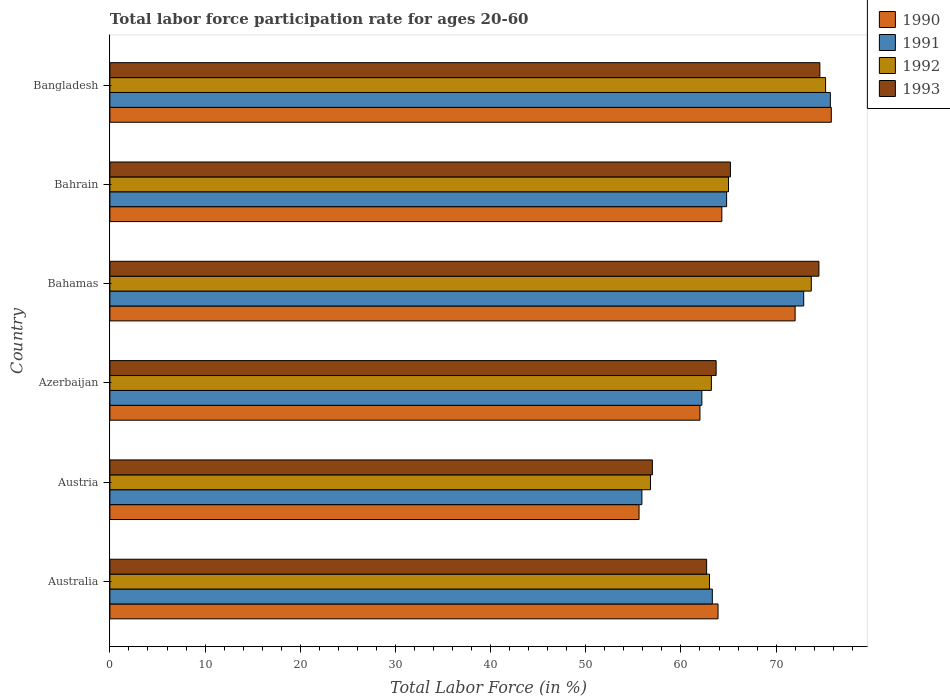Are the number of bars per tick equal to the number of legend labels?
Your answer should be compact. Yes. Are the number of bars on each tick of the Y-axis equal?
Your response must be concise. Yes. How many bars are there on the 1st tick from the top?
Your answer should be compact. 4. What is the label of the 6th group of bars from the top?
Offer a terse response. Australia. What is the labor force participation rate in 1990 in Bahamas?
Keep it short and to the point. 72. Across all countries, what is the maximum labor force participation rate in 1991?
Offer a terse response. 75.7. Across all countries, what is the minimum labor force participation rate in 1993?
Your answer should be compact. 57. In which country was the labor force participation rate in 1990 maximum?
Provide a short and direct response. Bangladesh. What is the total labor force participation rate in 1992 in the graph?
Your answer should be very brief. 396.9. What is the difference between the labor force participation rate in 1991 in Australia and that in Azerbaijan?
Ensure brevity in your answer.  1.1. What is the difference between the labor force participation rate in 1993 in Bahrain and the labor force participation rate in 1990 in Bahamas?
Your answer should be compact. -6.8. What is the average labor force participation rate in 1992 per country?
Provide a succinct answer. 66.15. What is the difference between the labor force participation rate in 1990 and labor force participation rate in 1992 in Azerbaijan?
Your answer should be very brief. -1.2. What is the ratio of the labor force participation rate in 1993 in Austria to that in Azerbaijan?
Provide a succinct answer. 0.89. Is the difference between the labor force participation rate in 1990 in Austria and Azerbaijan greater than the difference between the labor force participation rate in 1992 in Austria and Azerbaijan?
Ensure brevity in your answer.  Yes. What is the difference between the highest and the second highest labor force participation rate in 1993?
Your answer should be compact. 0.1. What is the difference between the highest and the lowest labor force participation rate in 1991?
Your answer should be very brief. 19.8. In how many countries, is the labor force participation rate in 1992 greater than the average labor force participation rate in 1992 taken over all countries?
Offer a very short reply. 2. What does the 4th bar from the bottom in Bahrain represents?
Your answer should be compact. 1993. Is it the case that in every country, the sum of the labor force participation rate in 1990 and labor force participation rate in 1991 is greater than the labor force participation rate in 1993?
Keep it short and to the point. Yes. Are all the bars in the graph horizontal?
Your response must be concise. Yes. Are the values on the major ticks of X-axis written in scientific E-notation?
Your answer should be very brief. No. Does the graph contain any zero values?
Offer a very short reply. No. Does the graph contain grids?
Keep it short and to the point. No. Where does the legend appear in the graph?
Your response must be concise. Top right. How many legend labels are there?
Your response must be concise. 4. How are the legend labels stacked?
Your answer should be compact. Vertical. What is the title of the graph?
Your answer should be very brief. Total labor force participation rate for ages 20-60. Does "1992" appear as one of the legend labels in the graph?
Provide a short and direct response. Yes. What is the label or title of the Y-axis?
Provide a short and direct response. Country. What is the Total Labor Force (in %) in 1990 in Australia?
Offer a terse response. 63.9. What is the Total Labor Force (in %) in 1991 in Australia?
Your answer should be very brief. 63.3. What is the Total Labor Force (in %) in 1993 in Australia?
Offer a terse response. 62.7. What is the Total Labor Force (in %) of 1990 in Austria?
Make the answer very short. 55.6. What is the Total Labor Force (in %) of 1991 in Austria?
Give a very brief answer. 55.9. What is the Total Labor Force (in %) of 1992 in Austria?
Ensure brevity in your answer.  56.8. What is the Total Labor Force (in %) in 1993 in Austria?
Offer a terse response. 57. What is the Total Labor Force (in %) in 1991 in Azerbaijan?
Your answer should be very brief. 62.2. What is the Total Labor Force (in %) of 1992 in Azerbaijan?
Give a very brief answer. 63.2. What is the Total Labor Force (in %) of 1993 in Azerbaijan?
Make the answer very short. 63.7. What is the Total Labor Force (in %) in 1990 in Bahamas?
Give a very brief answer. 72. What is the Total Labor Force (in %) in 1991 in Bahamas?
Offer a terse response. 72.9. What is the Total Labor Force (in %) in 1992 in Bahamas?
Keep it short and to the point. 73.7. What is the Total Labor Force (in %) of 1993 in Bahamas?
Give a very brief answer. 74.5. What is the Total Labor Force (in %) in 1990 in Bahrain?
Your response must be concise. 64.3. What is the Total Labor Force (in %) of 1991 in Bahrain?
Your response must be concise. 64.8. What is the Total Labor Force (in %) of 1992 in Bahrain?
Your answer should be very brief. 65. What is the Total Labor Force (in %) of 1993 in Bahrain?
Your response must be concise. 65.2. What is the Total Labor Force (in %) of 1990 in Bangladesh?
Your response must be concise. 75.8. What is the Total Labor Force (in %) of 1991 in Bangladesh?
Your answer should be very brief. 75.7. What is the Total Labor Force (in %) of 1992 in Bangladesh?
Your answer should be very brief. 75.2. What is the Total Labor Force (in %) of 1993 in Bangladesh?
Provide a succinct answer. 74.6. Across all countries, what is the maximum Total Labor Force (in %) in 1990?
Your answer should be very brief. 75.8. Across all countries, what is the maximum Total Labor Force (in %) of 1991?
Keep it short and to the point. 75.7. Across all countries, what is the maximum Total Labor Force (in %) in 1992?
Ensure brevity in your answer.  75.2. Across all countries, what is the maximum Total Labor Force (in %) of 1993?
Offer a terse response. 74.6. Across all countries, what is the minimum Total Labor Force (in %) of 1990?
Your response must be concise. 55.6. Across all countries, what is the minimum Total Labor Force (in %) in 1991?
Provide a short and direct response. 55.9. Across all countries, what is the minimum Total Labor Force (in %) in 1992?
Your answer should be compact. 56.8. What is the total Total Labor Force (in %) in 1990 in the graph?
Make the answer very short. 393.6. What is the total Total Labor Force (in %) in 1991 in the graph?
Your answer should be compact. 394.8. What is the total Total Labor Force (in %) of 1992 in the graph?
Your answer should be very brief. 396.9. What is the total Total Labor Force (in %) of 1993 in the graph?
Provide a short and direct response. 397.7. What is the difference between the Total Labor Force (in %) of 1992 in Australia and that in Austria?
Offer a terse response. 6.2. What is the difference between the Total Labor Force (in %) in 1991 in Australia and that in Azerbaijan?
Ensure brevity in your answer.  1.1. What is the difference between the Total Labor Force (in %) in 1992 in Australia and that in Azerbaijan?
Ensure brevity in your answer.  -0.2. What is the difference between the Total Labor Force (in %) of 1993 in Australia and that in Azerbaijan?
Your answer should be compact. -1. What is the difference between the Total Labor Force (in %) of 1992 in Australia and that in Bahamas?
Provide a short and direct response. -10.7. What is the difference between the Total Labor Force (in %) in 1993 in Australia and that in Bahamas?
Make the answer very short. -11.8. What is the difference between the Total Labor Force (in %) of 1990 in Australia and that in Bahrain?
Ensure brevity in your answer.  -0.4. What is the difference between the Total Labor Force (in %) in 1992 in Australia and that in Bahrain?
Provide a short and direct response. -2. What is the difference between the Total Labor Force (in %) of 1990 in Australia and that in Bangladesh?
Your answer should be compact. -11.9. What is the difference between the Total Labor Force (in %) of 1991 in Australia and that in Bangladesh?
Give a very brief answer. -12.4. What is the difference between the Total Labor Force (in %) in 1993 in Australia and that in Bangladesh?
Give a very brief answer. -11.9. What is the difference between the Total Labor Force (in %) in 1991 in Austria and that in Azerbaijan?
Your answer should be very brief. -6.3. What is the difference between the Total Labor Force (in %) of 1992 in Austria and that in Azerbaijan?
Make the answer very short. -6.4. What is the difference between the Total Labor Force (in %) of 1993 in Austria and that in Azerbaijan?
Your response must be concise. -6.7. What is the difference between the Total Labor Force (in %) in 1990 in Austria and that in Bahamas?
Ensure brevity in your answer.  -16.4. What is the difference between the Total Labor Force (in %) in 1992 in Austria and that in Bahamas?
Offer a terse response. -16.9. What is the difference between the Total Labor Force (in %) of 1993 in Austria and that in Bahamas?
Offer a terse response. -17.5. What is the difference between the Total Labor Force (in %) of 1991 in Austria and that in Bahrain?
Keep it short and to the point. -8.9. What is the difference between the Total Labor Force (in %) of 1992 in Austria and that in Bahrain?
Offer a terse response. -8.2. What is the difference between the Total Labor Force (in %) in 1993 in Austria and that in Bahrain?
Offer a terse response. -8.2. What is the difference between the Total Labor Force (in %) of 1990 in Austria and that in Bangladesh?
Ensure brevity in your answer.  -20.2. What is the difference between the Total Labor Force (in %) of 1991 in Austria and that in Bangladesh?
Ensure brevity in your answer.  -19.8. What is the difference between the Total Labor Force (in %) in 1992 in Austria and that in Bangladesh?
Keep it short and to the point. -18.4. What is the difference between the Total Labor Force (in %) in 1993 in Austria and that in Bangladesh?
Ensure brevity in your answer.  -17.6. What is the difference between the Total Labor Force (in %) in 1990 in Azerbaijan and that in Bahamas?
Offer a terse response. -10. What is the difference between the Total Labor Force (in %) of 1991 in Azerbaijan and that in Bahrain?
Offer a very short reply. -2.6. What is the difference between the Total Labor Force (in %) of 1991 in Azerbaijan and that in Bangladesh?
Ensure brevity in your answer.  -13.5. What is the difference between the Total Labor Force (in %) in 1993 in Azerbaijan and that in Bangladesh?
Provide a succinct answer. -10.9. What is the difference between the Total Labor Force (in %) in 1991 in Bahamas and that in Bahrain?
Your response must be concise. 8.1. What is the difference between the Total Labor Force (in %) in 1992 in Bahamas and that in Bahrain?
Your answer should be very brief. 8.7. What is the difference between the Total Labor Force (in %) of 1991 in Bahamas and that in Bangladesh?
Your answer should be very brief. -2.8. What is the difference between the Total Labor Force (in %) of 1992 in Bahamas and that in Bangladesh?
Keep it short and to the point. -1.5. What is the difference between the Total Labor Force (in %) of 1991 in Bahrain and that in Bangladesh?
Ensure brevity in your answer.  -10.9. What is the difference between the Total Labor Force (in %) of 1992 in Bahrain and that in Bangladesh?
Provide a short and direct response. -10.2. What is the difference between the Total Labor Force (in %) of 1990 in Australia and the Total Labor Force (in %) of 1993 in Austria?
Provide a succinct answer. 6.9. What is the difference between the Total Labor Force (in %) of 1991 in Australia and the Total Labor Force (in %) of 1993 in Austria?
Ensure brevity in your answer.  6.3. What is the difference between the Total Labor Force (in %) of 1990 in Australia and the Total Labor Force (in %) of 1991 in Azerbaijan?
Your answer should be very brief. 1.7. What is the difference between the Total Labor Force (in %) in 1990 in Australia and the Total Labor Force (in %) in 1992 in Azerbaijan?
Keep it short and to the point. 0.7. What is the difference between the Total Labor Force (in %) in 1992 in Australia and the Total Labor Force (in %) in 1993 in Azerbaijan?
Offer a very short reply. -0.7. What is the difference between the Total Labor Force (in %) in 1990 in Australia and the Total Labor Force (in %) in 1991 in Bahamas?
Offer a very short reply. -9. What is the difference between the Total Labor Force (in %) of 1990 in Australia and the Total Labor Force (in %) of 1993 in Bahamas?
Your answer should be compact. -10.6. What is the difference between the Total Labor Force (in %) of 1991 in Australia and the Total Labor Force (in %) of 1992 in Bahamas?
Give a very brief answer. -10.4. What is the difference between the Total Labor Force (in %) in 1991 in Australia and the Total Labor Force (in %) in 1993 in Bahamas?
Your response must be concise. -11.2. What is the difference between the Total Labor Force (in %) of 1992 in Australia and the Total Labor Force (in %) of 1993 in Bahamas?
Offer a terse response. -11.5. What is the difference between the Total Labor Force (in %) in 1991 in Australia and the Total Labor Force (in %) in 1993 in Bahrain?
Keep it short and to the point. -1.9. What is the difference between the Total Labor Force (in %) in 1990 in Australia and the Total Labor Force (in %) in 1991 in Bangladesh?
Offer a very short reply. -11.8. What is the difference between the Total Labor Force (in %) in 1990 in Australia and the Total Labor Force (in %) in 1992 in Bangladesh?
Offer a very short reply. -11.3. What is the difference between the Total Labor Force (in %) in 1990 in Australia and the Total Labor Force (in %) in 1993 in Bangladesh?
Offer a terse response. -10.7. What is the difference between the Total Labor Force (in %) in 1991 in Australia and the Total Labor Force (in %) in 1992 in Bangladesh?
Ensure brevity in your answer.  -11.9. What is the difference between the Total Labor Force (in %) of 1990 in Austria and the Total Labor Force (in %) of 1992 in Azerbaijan?
Provide a short and direct response. -7.6. What is the difference between the Total Labor Force (in %) in 1990 in Austria and the Total Labor Force (in %) in 1993 in Azerbaijan?
Offer a terse response. -8.1. What is the difference between the Total Labor Force (in %) in 1990 in Austria and the Total Labor Force (in %) in 1991 in Bahamas?
Ensure brevity in your answer.  -17.3. What is the difference between the Total Labor Force (in %) in 1990 in Austria and the Total Labor Force (in %) in 1992 in Bahamas?
Your answer should be compact. -18.1. What is the difference between the Total Labor Force (in %) of 1990 in Austria and the Total Labor Force (in %) of 1993 in Bahamas?
Your answer should be compact. -18.9. What is the difference between the Total Labor Force (in %) in 1991 in Austria and the Total Labor Force (in %) in 1992 in Bahamas?
Provide a succinct answer. -17.8. What is the difference between the Total Labor Force (in %) in 1991 in Austria and the Total Labor Force (in %) in 1993 in Bahamas?
Provide a short and direct response. -18.6. What is the difference between the Total Labor Force (in %) of 1992 in Austria and the Total Labor Force (in %) of 1993 in Bahamas?
Offer a very short reply. -17.7. What is the difference between the Total Labor Force (in %) of 1990 in Austria and the Total Labor Force (in %) of 1992 in Bahrain?
Make the answer very short. -9.4. What is the difference between the Total Labor Force (in %) of 1990 in Austria and the Total Labor Force (in %) of 1993 in Bahrain?
Ensure brevity in your answer.  -9.6. What is the difference between the Total Labor Force (in %) of 1991 in Austria and the Total Labor Force (in %) of 1993 in Bahrain?
Give a very brief answer. -9.3. What is the difference between the Total Labor Force (in %) in 1990 in Austria and the Total Labor Force (in %) in 1991 in Bangladesh?
Give a very brief answer. -20.1. What is the difference between the Total Labor Force (in %) in 1990 in Austria and the Total Labor Force (in %) in 1992 in Bangladesh?
Keep it short and to the point. -19.6. What is the difference between the Total Labor Force (in %) in 1990 in Austria and the Total Labor Force (in %) in 1993 in Bangladesh?
Provide a short and direct response. -19. What is the difference between the Total Labor Force (in %) in 1991 in Austria and the Total Labor Force (in %) in 1992 in Bangladesh?
Make the answer very short. -19.3. What is the difference between the Total Labor Force (in %) of 1991 in Austria and the Total Labor Force (in %) of 1993 in Bangladesh?
Provide a succinct answer. -18.7. What is the difference between the Total Labor Force (in %) of 1992 in Austria and the Total Labor Force (in %) of 1993 in Bangladesh?
Provide a short and direct response. -17.8. What is the difference between the Total Labor Force (in %) in 1990 in Azerbaijan and the Total Labor Force (in %) in 1991 in Bahamas?
Give a very brief answer. -10.9. What is the difference between the Total Labor Force (in %) in 1992 in Azerbaijan and the Total Labor Force (in %) in 1993 in Bahamas?
Ensure brevity in your answer.  -11.3. What is the difference between the Total Labor Force (in %) in 1990 in Azerbaijan and the Total Labor Force (in %) in 1991 in Bahrain?
Your response must be concise. -2.8. What is the difference between the Total Labor Force (in %) in 1990 in Azerbaijan and the Total Labor Force (in %) in 1992 in Bahrain?
Provide a succinct answer. -3. What is the difference between the Total Labor Force (in %) in 1990 in Azerbaijan and the Total Labor Force (in %) in 1993 in Bahrain?
Keep it short and to the point. -3.2. What is the difference between the Total Labor Force (in %) of 1991 in Azerbaijan and the Total Labor Force (in %) of 1992 in Bahrain?
Your answer should be very brief. -2.8. What is the difference between the Total Labor Force (in %) in 1992 in Azerbaijan and the Total Labor Force (in %) in 1993 in Bahrain?
Your answer should be compact. -2. What is the difference between the Total Labor Force (in %) of 1990 in Azerbaijan and the Total Labor Force (in %) of 1991 in Bangladesh?
Make the answer very short. -13.7. What is the difference between the Total Labor Force (in %) of 1990 in Azerbaijan and the Total Labor Force (in %) of 1992 in Bangladesh?
Your response must be concise. -13.2. What is the difference between the Total Labor Force (in %) in 1991 in Azerbaijan and the Total Labor Force (in %) in 1993 in Bangladesh?
Your answer should be very brief. -12.4. What is the difference between the Total Labor Force (in %) of 1990 in Bahamas and the Total Labor Force (in %) of 1991 in Bahrain?
Make the answer very short. 7.2. What is the difference between the Total Labor Force (in %) of 1990 in Bahamas and the Total Labor Force (in %) of 1992 in Bahrain?
Provide a succinct answer. 7. What is the difference between the Total Labor Force (in %) in 1991 in Bahamas and the Total Labor Force (in %) in 1992 in Bahrain?
Your response must be concise. 7.9. What is the difference between the Total Labor Force (in %) in 1991 in Bahamas and the Total Labor Force (in %) in 1993 in Bahrain?
Offer a terse response. 7.7. What is the difference between the Total Labor Force (in %) in 1990 in Bahrain and the Total Labor Force (in %) in 1993 in Bangladesh?
Give a very brief answer. -10.3. What is the average Total Labor Force (in %) of 1990 per country?
Your answer should be very brief. 65.6. What is the average Total Labor Force (in %) of 1991 per country?
Give a very brief answer. 65.8. What is the average Total Labor Force (in %) of 1992 per country?
Provide a short and direct response. 66.15. What is the average Total Labor Force (in %) in 1993 per country?
Ensure brevity in your answer.  66.28. What is the difference between the Total Labor Force (in %) in 1991 and Total Labor Force (in %) in 1992 in Australia?
Your answer should be compact. 0.3. What is the difference between the Total Labor Force (in %) of 1990 and Total Labor Force (in %) of 1993 in Austria?
Provide a succinct answer. -1.4. What is the difference between the Total Labor Force (in %) of 1990 and Total Labor Force (in %) of 1993 in Azerbaijan?
Your answer should be very brief. -1.7. What is the difference between the Total Labor Force (in %) of 1991 and Total Labor Force (in %) of 1993 in Azerbaijan?
Keep it short and to the point. -1.5. What is the difference between the Total Labor Force (in %) of 1990 and Total Labor Force (in %) of 1991 in Bahamas?
Your answer should be very brief. -0.9. What is the difference between the Total Labor Force (in %) of 1990 and Total Labor Force (in %) of 1993 in Bahamas?
Offer a very short reply. -2.5. What is the difference between the Total Labor Force (in %) in 1991 and Total Labor Force (in %) in 1992 in Bahamas?
Your response must be concise. -0.8. What is the difference between the Total Labor Force (in %) of 1992 and Total Labor Force (in %) of 1993 in Bahamas?
Offer a terse response. -0.8. What is the difference between the Total Labor Force (in %) of 1990 and Total Labor Force (in %) of 1991 in Bangladesh?
Your response must be concise. 0.1. What is the difference between the Total Labor Force (in %) of 1990 and Total Labor Force (in %) of 1992 in Bangladesh?
Your answer should be compact. 0.6. What is the difference between the Total Labor Force (in %) in 1990 and Total Labor Force (in %) in 1993 in Bangladesh?
Provide a short and direct response. 1.2. What is the difference between the Total Labor Force (in %) of 1991 and Total Labor Force (in %) of 1992 in Bangladesh?
Offer a terse response. 0.5. What is the difference between the Total Labor Force (in %) in 1991 and Total Labor Force (in %) in 1993 in Bangladesh?
Provide a short and direct response. 1.1. What is the difference between the Total Labor Force (in %) in 1992 and Total Labor Force (in %) in 1993 in Bangladesh?
Your answer should be compact. 0.6. What is the ratio of the Total Labor Force (in %) of 1990 in Australia to that in Austria?
Provide a short and direct response. 1.15. What is the ratio of the Total Labor Force (in %) in 1991 in Australia to that in Austria?
Keep it short and to the point. 1.13. What is the ratio of the Total Labor Force (in %) in 1992 in Australia to that in Austria?
Ensure brevity in your answer.  1.11. What is the ratio of the Total Labor Force (in %) of 1990 in Australia to that in Azerbaijan?
Give a very brief answer. 1.03. What is the ratio of the Total Labor Force (in %) of 1991 in Australia to that in Azerbaijan?
Your answer should be very brief. 1.02. What is the ratio of the Total Labor Force (in %) of 1993 in Australia to that in Azerbaijan?
Offer a very short reply. 0.98. What is the ratio of the Total Labor Force (in %) of 1990 in Australia to that in Bahamas?
Your answer should be very brief. 0.89. What is the ratio of the Total Labor Force (in %) of 1991 in Australia to that in Bahamas?
Keep it short and to the point. 0.87. What is the ratio of the Total Labor Force (in %) in 1992 in Australia to that in Bahamas?
Offer a terse response. 0.85. What is the ratio of the Total Labor Force (in %) in 1993 in Australia to that in Bahamas?
Give a very brief answer. 0.84. What is the ratio of the Total Labor Force (in %) in 1990 in Australia to that in Bahrain?
Keep it short and to the point. 0.99. What is the ratio of the Total Labor Force (in %) in 1991 in Australia to that in Bahrain?
Keep it short and to the point. 0.98. What is the ratio of the Total Labor Force (in %) in 1992 in Australia to that in Bahrain?
Your response must be concise. 0.97. What is the ratio of the Total Labor Force (in %) in 1993 in Australia to that in Bahrain?
Provide a short and direct response. 0.96. What is the ratio of the Total Labor Force (in %) in 1990 in Australia to that in Bangladesh?
Your response must be concise. 0.84. What is the ratio of the Total Labor Force (in %) of 1991 in Australia to that in Bangladesh?
Provide a short and direct response. 0.84. What is the ratio of the Total Labor Force (in %) in 1992 in Australia to that in Bangladesh?
Ensure brevity in your answer.  0.84. What is the ratio of the Total Labor Force (in %) of 1993 in Australia to that in Bangladesh?
Ensure brevity in your answer.  0.84. What is the ratio of the Total Labor Force (in %) of 1990 in Austria to that in Azerbaijan?
Ensure brevity in your answer.  0.9. What is the ratio of the Total Labor Force (in %) in 1991 in Austria to that in Azerbaijan?
Make the answer very short. 0.9. What is the ratio of the Total Labor Force (in %) of 1992 in Austria to that in Azerbaijan?
Ensure brevity in your answer.  0.9. What is the ratio of the Total Labor Force (in %) of 1993 in Austria to that in Azerbaijan?
Keep it short and to the point. 0.89. What is the ratio of the Total Labor Force (in %) in 1990 in Austria to that in Bahamas?
Provide a succinct answer. 0.77. What is the ratio of the Total Labor Force (in %) of 1991 in Austria to that in Bahamas?
Keep it short and to the point. 0.77. What is the ratio of the Total Labor Force (in %) in 1992 in Austria to that in Bahamas?
Offer a terse response. 0.77. What is the ratio of the Total Labor Force (in %) of 1993 in Austria to that in Bahamas?
Offer a terse response. 0.77. What is the ratio of the Total Labor Force (in %) in 1990 in Austria to that in Bahrain?
Provide a succinct answer. 0.86. What is the ratio of the Total Labor Force (in %) of 1991 in Austria to that in Bahrain?
Your response must be concise. 0.86. What is the ratio of the Total Labor Force (in %) in 1992 in Austria to that in Bahrain?
Ensure brevity in your answer.  0.87. What is the ratio of the Total Labor Force (in %) in 1993 in Austria to that in Bahrain?
Make the answer very short. 0.87. What is the ratio of the Total Labor Force (in %) of 1990 in Austria to that in Bangladesh?
Your response must be concise. 0.73. What is the ratio of the Total Labor Force (in %) of 1991 in Austria to that in Bangladesh?
Your answer should be compact. 0.74. What is the ratio of the Total Labor Force (in %) of 1992 in Austria to that in Bangladesh?
Make the answer very short. 0.76. What is the ratio of the Total Labor Force (in %) of 1993 in Austria to that in Bangladesh?
Provide a succinct answer. 0.76. What is the ratio of the Total Labor Force (in %) in 1990 in Azerbaijan to that in Bahamas?
Keep it short and to the point. 0.86. What is the ratio of the Total Labor Force (in %) in 1991 in Azerbaijan to that in Bahamas?
Provide a short and direct response. 0.85. What is the ratio of the Total Labor Force (in %) in 1992 in Azerbaijan to that in Bahamas?
Provide a succinct answer. 0.86. What is the ratio of the Total Labor Force (in %) of 1993 in Azerbaijan to that in Bahamas?
Provide a succinct answer. 0.85. What is the ratio of the Total Labor Force (in %) in 1990 in Azerbaijan to that in Bahrain?
Give a very brief answer. 0.96. What is the ratio of the Total Labor Force (in %) in 1991 in Azerbaijan to that in Bahrain?
Your answer should be compact. 0.96. What is the ratio of the Total Labor Force (in %) of 1992 in Azerbaijan to that in Bahrain?
Make the answer very short. 0.97. What is the ratio of the Total Labor Force (in %) in 1993 in Azerbaijan to that in Bahrain?
Give a very brief answer. 0.98. What is the ratio of the Total Labor Force (in %) of 1990 in Azerbaijan to that in Bangladesh?
Offer a very short reply. 0.82. What is the ratio of the Total Labor Force (in %) of 1991 in Azerbaijan to that in Bangladesh?
Offer a terse response. 0.82. What is the ratio of the Total Labor Force (in %) of 1992 in Azerbaijan to that in Bangladesh?
Give a very brief answer. 0.84. What is the ratio of the Total Labor Force (in %) of 1993 in Azerbaijan to that in Bangladesh?
Your answer should be compact. 0.85. What is the ratio of the Total Labor Force (in %) in 1990 in Bahamas to that in Bahrain?
Your answer should be compact. 1.12. What is the ratio of the Total Labor Force (in %) of 1992 in Bahamas to that in Bahrain?
Your response must be concise. 1.13. What is the ratio of the Total Labor Force (in %) of 1993 in Bahamas to that in Bahrain?
Ensure brevity in your answer.  1.14. What is the ratio of the Total Labor Force (in %) of 1990 in Bahamas to that in Bangladesh?
Offer a terse response. 0.95. What is the ratio of the Total Labor Force (in %) in 1991 in Bahamas to that in Bangladesh?
Keep it short and to the point. 0.96. What is the ratio of the Total Labor Force (in %) in 1992 in Bahamas to that in Bangladesh?
Keep it short and to the point. 0.98. What is the ratio of the Total Labor Force (in %) in 1990 in Bahrain to that in Bangladesh?
Your answer should be very brief. 0.85. What is the ratio of the Total Labor Force (in %) of 1991 in Bahrain to that in Bangladesh?
Offer a terse response. 0.86. What is the ratio of the Total Labor Force (in %) of 1992 in Bahrain to that in Bangladesh?
Give a very brief answer. 0.86. What is the ratio of the Total Labor Force (in %) of 1993 in Bahrain to that in Bangladesh?
Offer a very short reply. 0.87. What is the difference between the highest and the second highest Total Labor Force (in %) of 1992?
Give a very brief answer. 1.5. What is the difference between the highest and the second highest Total Labor Force (in %) in 1993?
Keep it short and to the point. 0.1. What is the difference between the highest and the lowest Total Labor Force (in %) in 1990?
Provide a short and direct response. 20.2. What is the difference between the highest and the lowest Total Labor Force (in %) of 1991?
Keep it short and to the point. 19.8. What is the difference between the highest and the lowest Total Labor Force (in %) in 1992?
Make the answer very short. 18.4. What is the difference between the highest and the lowest Total Labor Force (in %) in 1993?
Ensure brevity in your answer.  17.6. 